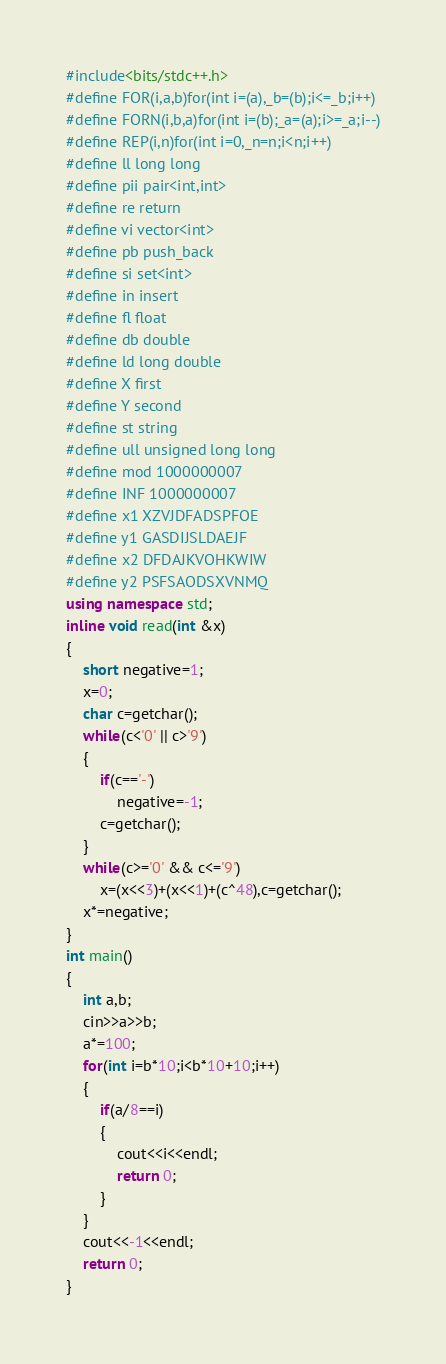Convert code to text. <code><loc_0><loc_0><loc_500><loc_500><_C++_>#include<bits/stdc++.h>
#define FOR(i,a,b)for(int i=(a),_b=(b);i<=_b;i++)
#define FORN(i,b,a)for(int i=(b);_a=(a);i>=_a;i--)
#define REP(i,n)for(int i=0,_n=n;i<n;i++)
#define ll long long
#define pii pair<int,int>
#define re return
#define vi vector<int>
#define pb push_back
#define si set<int>
#define in insert
#define fl float
#define db double
#define ld long double
#define X first
#define Y second
#define st string
#define ull unsigned long long
#define mod 1000000007
#define INF 1000000007
#define x1 XZVJDFADSPFOE
#define y1 GASDIJSLDAEJF
#define x2 DFDAJKVOHKWIW
#define y2 PSFSAODSXVNMQ
using namespace std;
inline void read(int &x)
{
	short negative=1;
    x=0;
    char c=getchar();
    while(c<'0' || c>'9')
    {
		if(c=='-')
			negative=-1;
		c=getchar();
	}
    while(c>='0' && c<='9')
        x=(x<<3)+(x<<1)+(c^48),c=getchar();
    x*=negative;
}
int main()
{
	int a,b;
	cin>>a>>b;
	a*=100;
	for(int i=b*10;i<b*10+10;i++)
	{
		if(a/8==i)
		{
			cout<<i<<endl;
			return 0; 
		}
	}
	cout<<-1<<endl;
	return 0;
}

</code> 